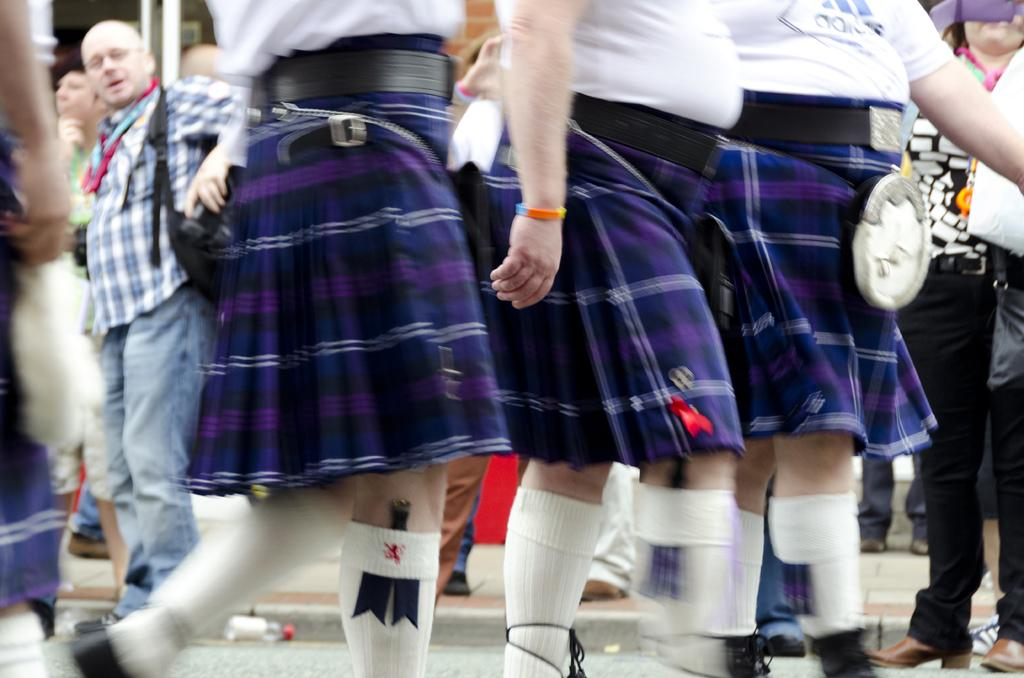How many people are in the image? There are three persons in the image. What are the persons wearing? The persons are wearing white t-shirts and blue skirts. What are the persons doing in the image? The persons are walking on the road. Can you describe the background of the image? There are people visible in the background of the image. What is the name of the sister of the person in the middle? There is no indication in the image that the persons are related, nor is there any information about their names. 